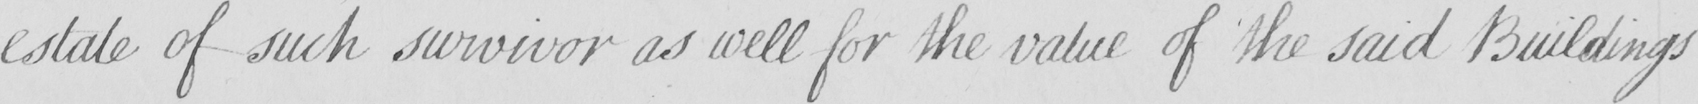Can you tell me what this handwritten text says? estate of such survivor as well for the value of the said Buildings 